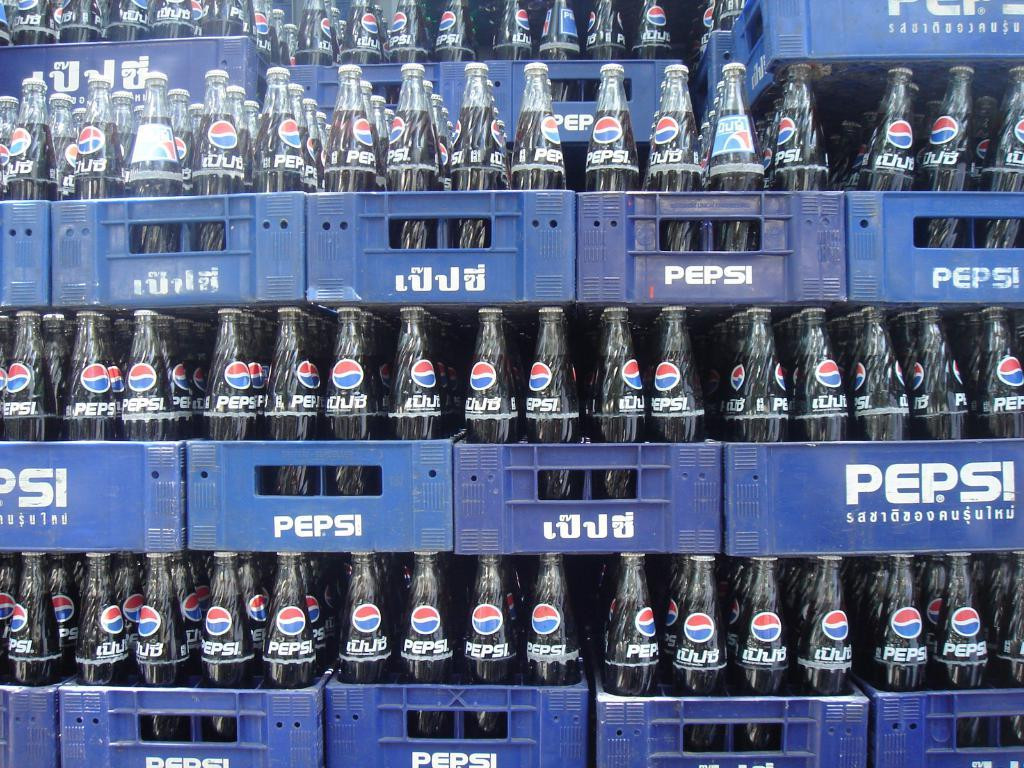Provide a one-sentence caption for the provided image. Several crates stacked on top of each other containing bottles of Pepsi. 